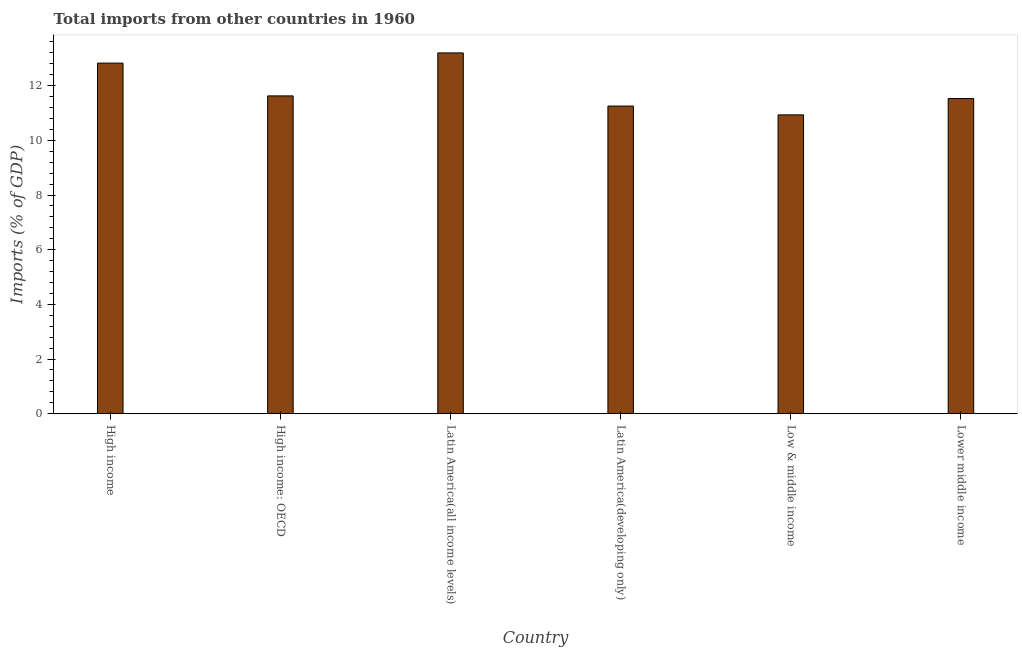Does the graph contain any zero values?
Ensure brevity in your answer.  No. What is the title of the graph?
Provide a short and direct response. Total imports from other countries in 1960. What is the label or title of the X-axis?
Provide a succinct answer. Country. What is the label or title of the Y-axis?
Give a very brief answer. Imports (% of GDP). What is the total imports in Lower middle income?
Your answer should be very brief. 11.53. Across all countries, what is the maximum total imports?
Offer a very short reply. 13.2. Across all countries, what is the minimum total imports?
Your response must be concise. 10.93. In which country was the total imports maximum?
Keep it short and to the point. Latin America(all income levels). What is the sum of the total imports?
Keep it short and to the point. 71.36. What is the difference between the total imports in High income and Latin America(developing only)?
Give a very brief answer. 1.57. What is the average total imports per country?
Offer a very short reply. 11.89. What is the median total imports?
Provide a succinct answer. 11.58. In how many countries, is the total imports greater than 6 %?
Make the answer very short. 6. What is the ratio of the total imports in Latin America(all income levels) to that in Latin America(developing only)?
Provide a succinct answer. 1.17. Is the difference between the total imports in Latin America(all income levels) and Low & middle income greater than the difference between any two countries?
Ensure brevity in your answer.  Yes. What is the difference between the highest and the second highest total imports?
Your response must be concise. 0.37. What is the difference between the highest and the lowest total imports?
Your answer should be very brief. 2.27. In how many countries, is the total imports greater than the average total imports taken over all countries?
Provide a succinct answer. 2. How many bars are there?
Keep it short and to the point. 6. How many countries are there in the graph?
Provide a short and direct response. 6. What is the difference between two consecutive major ticks on the Y-axis?
Your response must be concise. 2. What is the Imports (% of GDP) of High income?
Your answer should be compact. 12.82. What is the Imports (% of GDP) in High income: OECD?
Provide a short and direct response. 11.63. What is the Imports (% of GDP) of Latin America(all income levels)?
Your response must be concise. 13.2. What is the Imports (% of GDP) in Latin America(developing only)?
Make the answer very short. 11.25. What is the Imports (% of GDP) in Low & middle income?
Your answer should be compact. 10.93. What is the Imports (% of GDP) in Lower middle income?
Make the answer very short. 11.53. What is the difference between the Imports (% of GDP) in High income and High income: OECD?
Your response must be concise. 1.2. What is the difference between the Imports (% of GDP) in High income and Latin America(all income levels)?
Provide a short and direct response. -0.37. What is the difference between the Imports (% of GDP) in High income and Latin America(developing only)?
Ensure brevity in your answer.  1.57. What is the difference between the Imports (% of GDP) in High income and Low & middle income?
Ensure brevity in your answer.  1.89. What is the difference between the Imports (% of GDP) in High income and Lower middle income?
Provide a succinct answer. 1.3. What is the difference between the Imports (% of GDP) in High income: OECD and Latin America(all income levels)?
Provide a short and direct response. -1.57. What is the difference between the Imports (% of GDP) in High income: OECD and Latin America(developing only)?
Offer a very short reply. 0.37. What is the difference between the Imports (% of GDP) in High income: OECD and Low & middle income?
Keep it short and to the point. 0.69. What is the difference between the Imports (% of GDP) in High income: OECD and Lower middle income?
Give a very brief answer. 0.1. What is the difference between the Imports (% of GDP) in Latin America(all income levels) and Latin America(developing only)?
Give a very brief answer. 1.94. What is the difference between the Imports (% of GDP) in Latin America(all income levels) and Low & middle income?
Offer a very short reply. 2.27. What is the difference between the Imports (% of GDP) in Latin America(all income levels) and Lower middle income?
Keep it short and to the point. 1.67. What is the difference between the Imports (% of GDP) in Latin America(developing only) and Low & middle income?
Your answer should be compact. 0.32. What is the difference between the Imports (% of GDP) in Latin America(developing only) and Lower middle income?
Keep it short and to the point. -0.28. What is the difference between the Imports (% of GDP) in Low & middle income and Lower middle income?
Ensure brevity in your answer.  -0.6. What is the ratio of the Imports (% of GDP) in High income to that in High income: OECD?
Ensure brevity in your answer.  1.1. What is the ratio of the Imports (% of GDP) in High income to that in Latin America(all income levels)?
Ensure brevity in your answer.  0.97. What is the ratio of the Imports (% of GDP) in High income to that in Latin America(developing only)?
Ensure brevity in your answer.  1.14. What is the ratio of the Imports (% of GDP) in High income to that in Low & middle income?
Provide a short and direct response. 1.17. What is the ratio of the Imports (% of GDP) in High income to that in Lower middle income?
Your response must be concise. 1.11. What is the ratio of the Imports (% of GDP) in High income: OECD to that in Latin America(all income levels)?
Give a very brief answer. 0.88. What is the ratio of the Imports (% of GDP) in High income: OECD to that in Latin America(developing only)?
Make the answer very short. 1.03. What is the ratio of the Imports (% of GDP) in High income: OECD to that in Low & middle income?
Make the answer very short. 1.06. What is the ratio of the Imports (% of GDP) in High income: OECD to that in Lower middle income?
Provide a succinct answer. 1.01. What is the ratio of the Imports (% of GDP) in Latin America(all income levels) to that in Latin America(developing only)?
Provide a short and direct response. 1.17. What is the ratio of the Imports (% of GDP) in Latin America(all income levels) to that in Low & middle income?
Ensure brevity in your answer.  1.21. What is the ratio of the Imports (% of GDP) in Latin America(all income levels) to that in Lower middle income?
Your answer should be compact. 1.15. What is the ratio of the Imports (% of GDP) in Low & middle income to that in Lower middle income?
Offer a terse response. 0.95. 